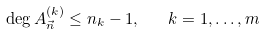<formula> <loc_0><loc_0><loc_500><loc_500>\deg A _ { \vec { n } } ^ { ( k ) } \leq n _ { k } - 1 , \quad k = 1 , \dots , m</formula> 